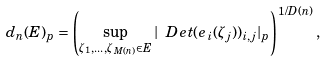<formula> <loc_0><loc_0><loc_500><loc_500>d _ { n } ( E ) _ { p } = \left ( \sup _ { \zeta _ { 1 } , \dots , \zeta _ { M ( n ) } \in E } | \ D e t ( e _ { i } ( \zeta _ { j } ) ) _ { i , j } | _ { p } \right ) ^ { 1 / D ( n ) } ,</formula> 